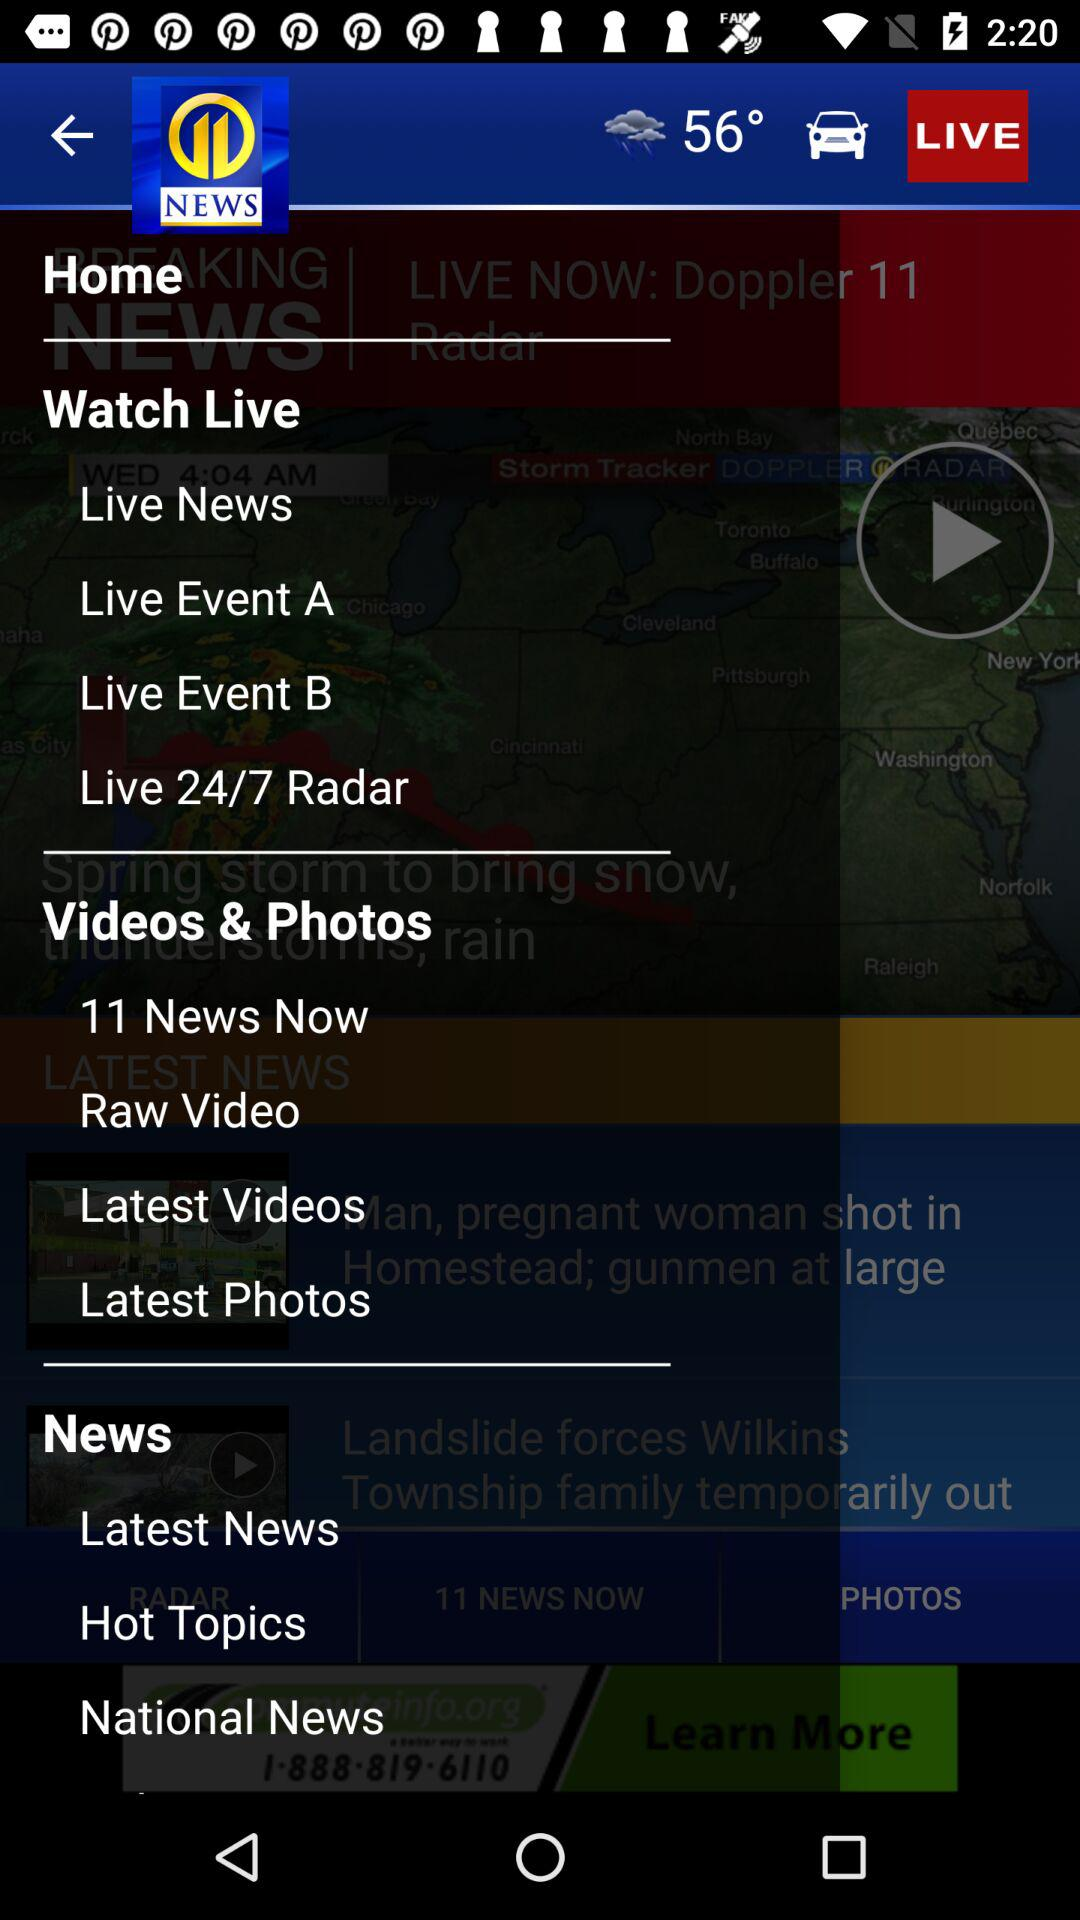What temperature is shown on the screen? The temperature shown on the screen is 56°. 